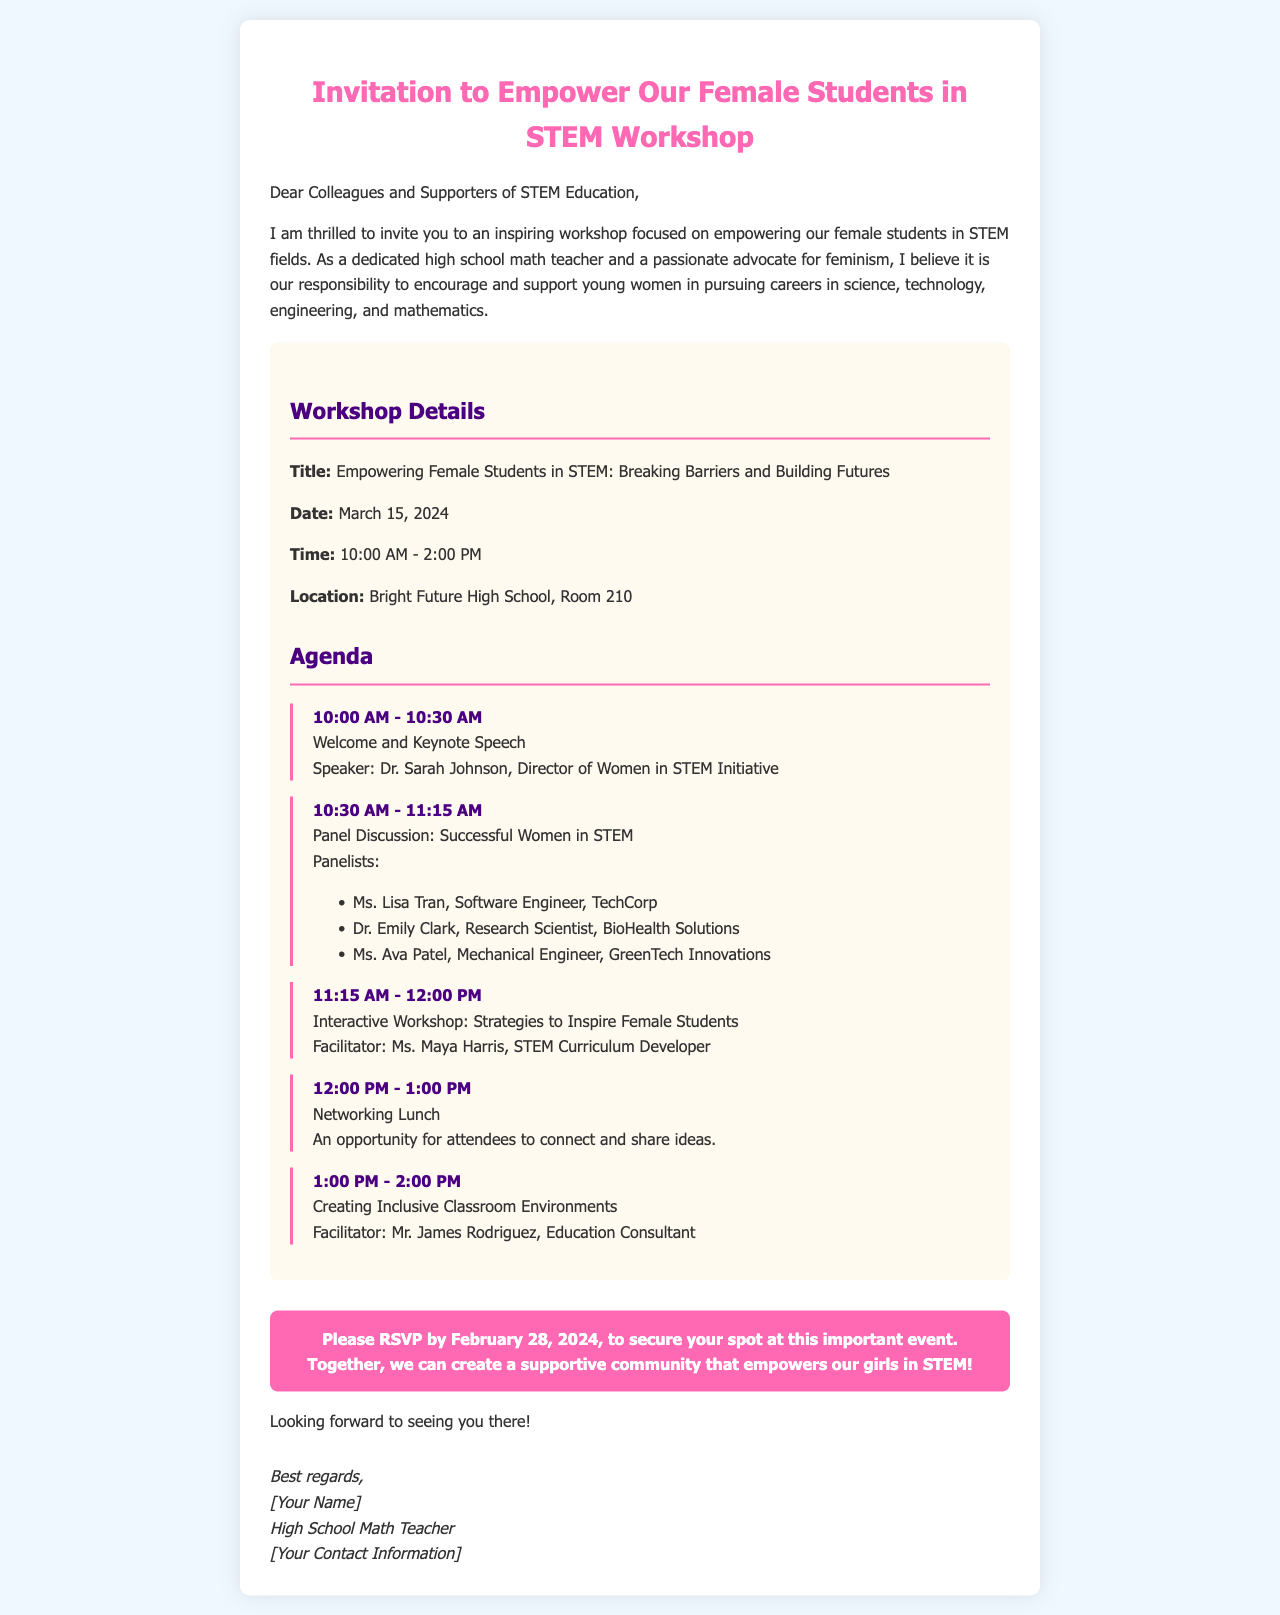What is the title of the workshop? The title of the workshop is "Empowering Female Students in STEM: Breaking Barriers and Building Futures."
Answer: Empowering Female Students in STEM: Breaking Barriers and Building Futures What date is the workshop scheduled for? The date of the workshop is mentioned in the document.
Answer: March 15, 2024 What time does the workshop start? The workshop starts at 10:00 AM as stated in the schedule.
Answer: 10:00 AM Who is the keynote speaker? The keynote speaker's name is listed in the agenda for the welcome session.
Answer: Dr. Sarah Johnson What is one of the topics covered in the workshop? The topics covered are listed under the agenda section, including "Panel Discussion: Successful Women in STEM."
Answer: Panel Discussion: Successful Women in STEM When is the RSVP deadline? The RSVP deadline is specified in the call-to-action section.
Answer: February 28, 2024 What is the location of the workshop? The location of the workshop is specified in the event details.
Answer: Bright Future High School, Room 210 Who is facilitating the interactive workshop? The facilitator's name is included in the agenda for the respective session.
Answer: Ms. Maya Harris What color is used for the heading of the invitation? The document describes the color style for the heading.
Answer: Pink 